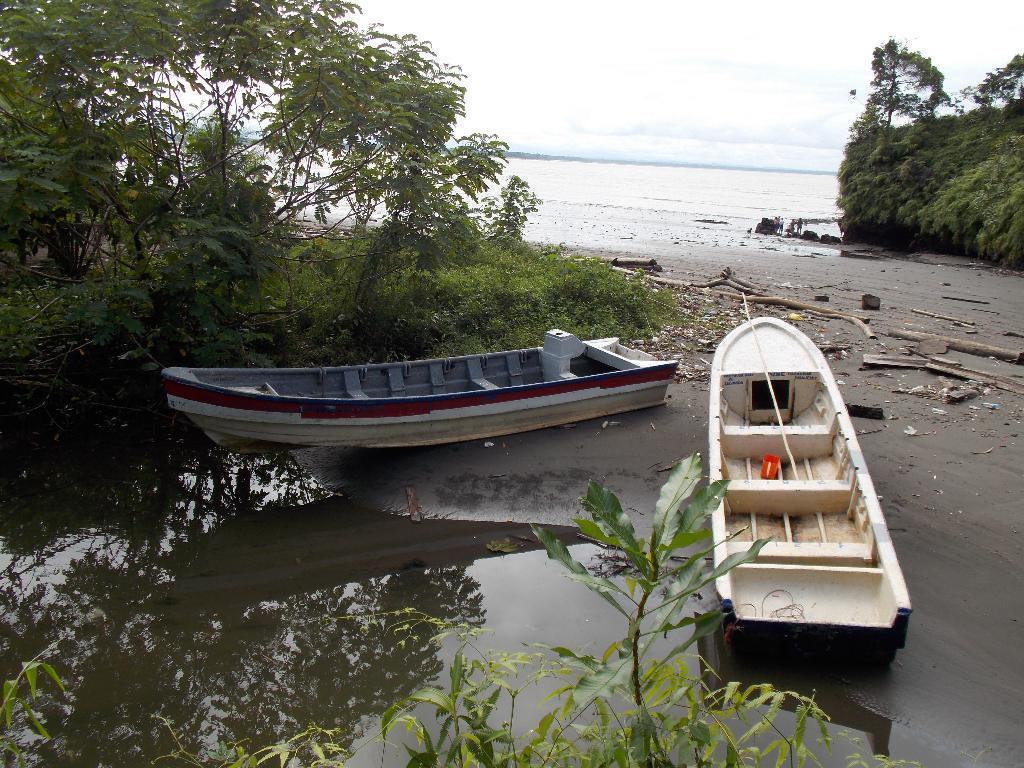How would you summarize this image in a sentence or two? In this picture we can see water, few trees and boats, in the background we can find group of people, and also we can see few wooden barks. 